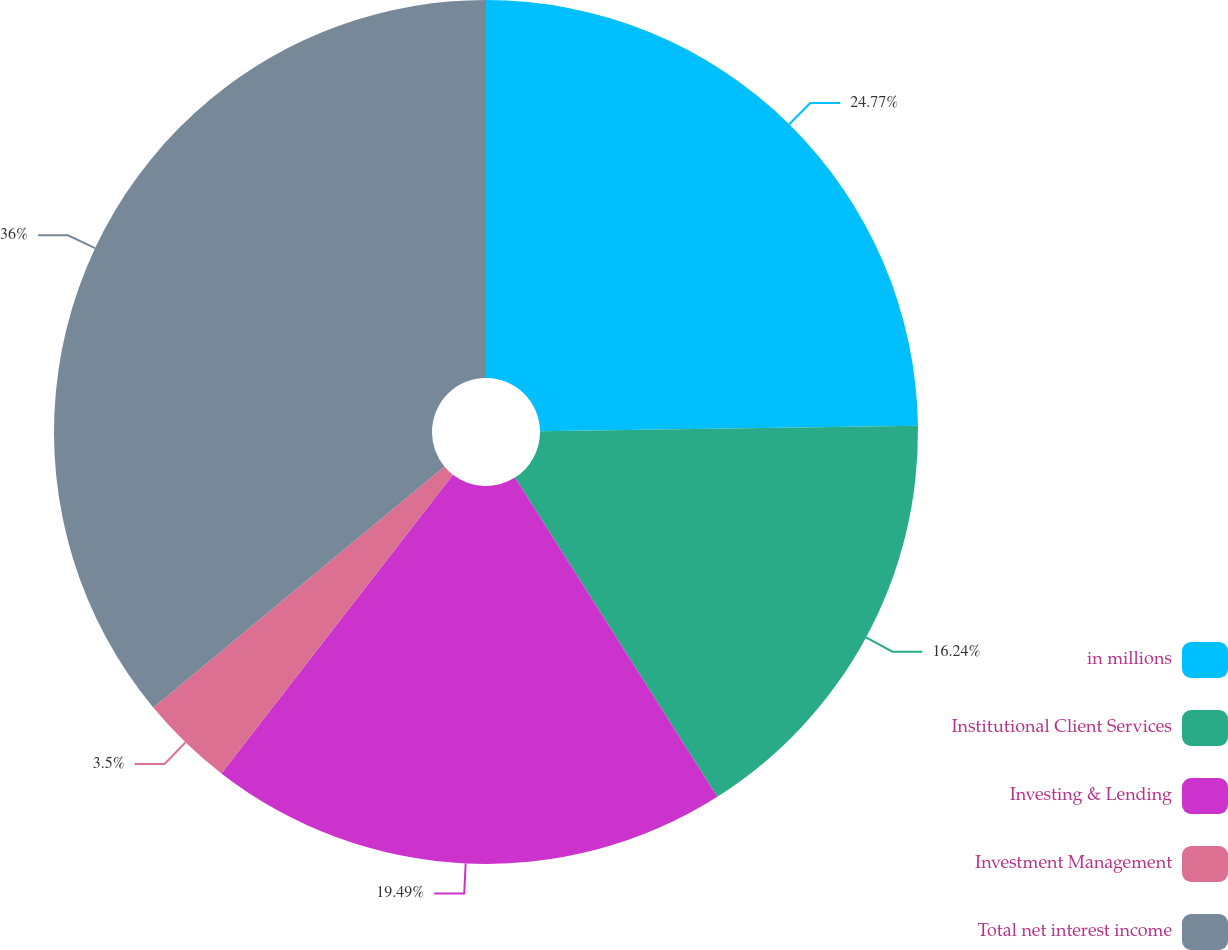Convert chart. <chart><loc_0><loc_0><loc_500><loc_500><pie_chart><fcel>in millions<fcel>Institutional Client Services<fcel>Investing & Lending<fcel>Investment Management<fcel>Total net interest income<nl><fcel>24.77%<fcel>16.24%<fcel>19.49%<fcel>3.5%<fcel>36.01%<nl></chart> 